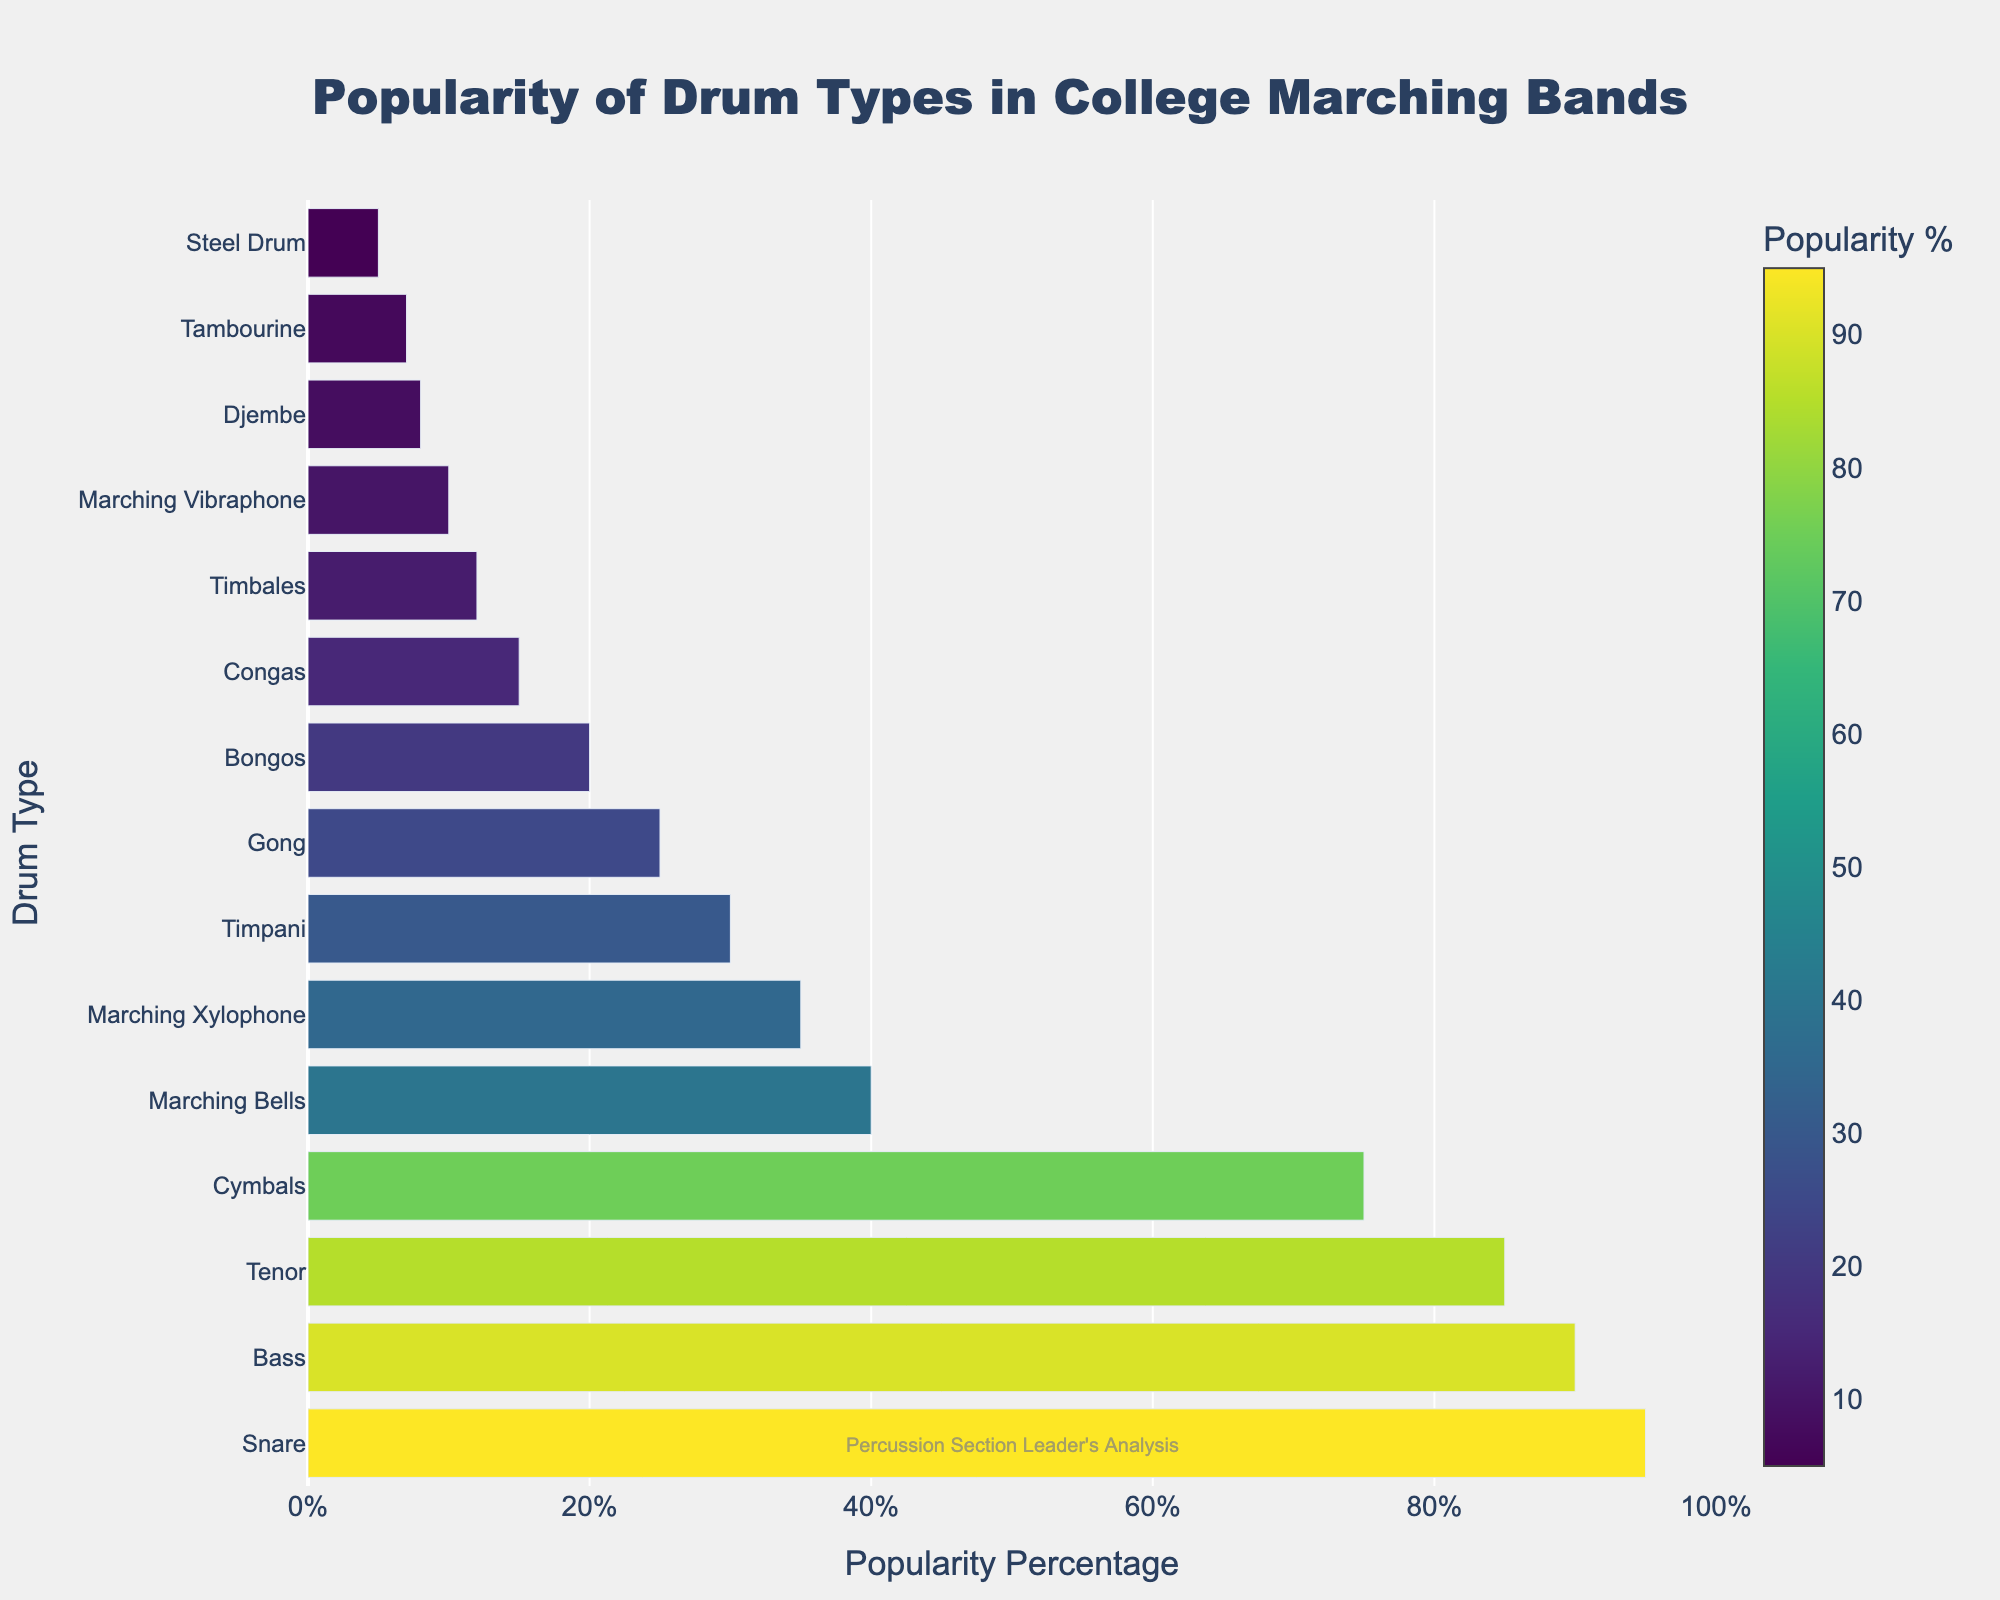Which drum type has the highest popularity percentage? The snare drum has the highest popularity percentage on the chart, as indicated by the bar length and the documented percentage value of 95%.
Answer: Snare Among the Bass and Tenor drums, which one is more popular and by how much? The Bass drum has a popularity percentage of 90%, while the Tenor drum has 85%. The difference is 90% - 85% = 5%.
Answer: Bass, by 5% What is the combined popularity percentage of the Marching Bells and Marching Xylophone? The Marching Bells have a popularity percentage of 40%, and the Marching Xylophone has 35%. The sum is 40% + 35% = 75%.
Answer: 75% Which drum type is more popular, the Gong or the Bongos, and by how much? The Gong has a popularity percentage of 25%, and the Bongos have 20%. The difference is 25% - 20% = 5%.
Answer: Gong, by 5% Which drum types have a popularity percentage higher than 50%? The drum types with a popularity percentage higher than 50% are Snare, Bass, Tenor, and Cymbals, as indicated by the values exceeding the 50% mark on the chart.
Answer: Snare, Bass, Tenor, Cymbals What’s the median popularity percentage of all the drum types listed? First, list the popularity percentages in ascending order: 5, 7, 8, 10, 12, 15, 20, 25, 30, 35, 40, 75, 85, 90, 95. Since there are 15 drum types, the median is the 8th value, which is 25%.
Answer: 25% Which drum types have a popularity percentage of less than 20%? The drum types with a popularity percentage less than 20% are Congas, Timbales, Marching Vibraphone, Djembe, Tambourine, and Steel Drum, as shown by their corresponding values on the chart.
Answer: Congas, Timbales, Marching Vibraphone, Djembe, Tambourine, Steel Drum Does the average popularity percentage of the drums in the top three positions exceed 90%? The top three drum types are Snare (95%), Bass (90%), and Tenor (85%). The average popularity percentage is (95% + 90% + 85%) / 3 = 90%. Therefore, it does not exceed 90%.
Answer: No What is the popularity percentage of the least popular drum type? The chart shows that the Steel Drum is the least popular with a popularity percentage of 5%.
Answer: 5% How many drum types have a popularity percentage between 30% and 75%? The drum types within this range are Marching Bells (40%), Marching Xylophone (35%), and Timpani (30%).
Answer: 3 